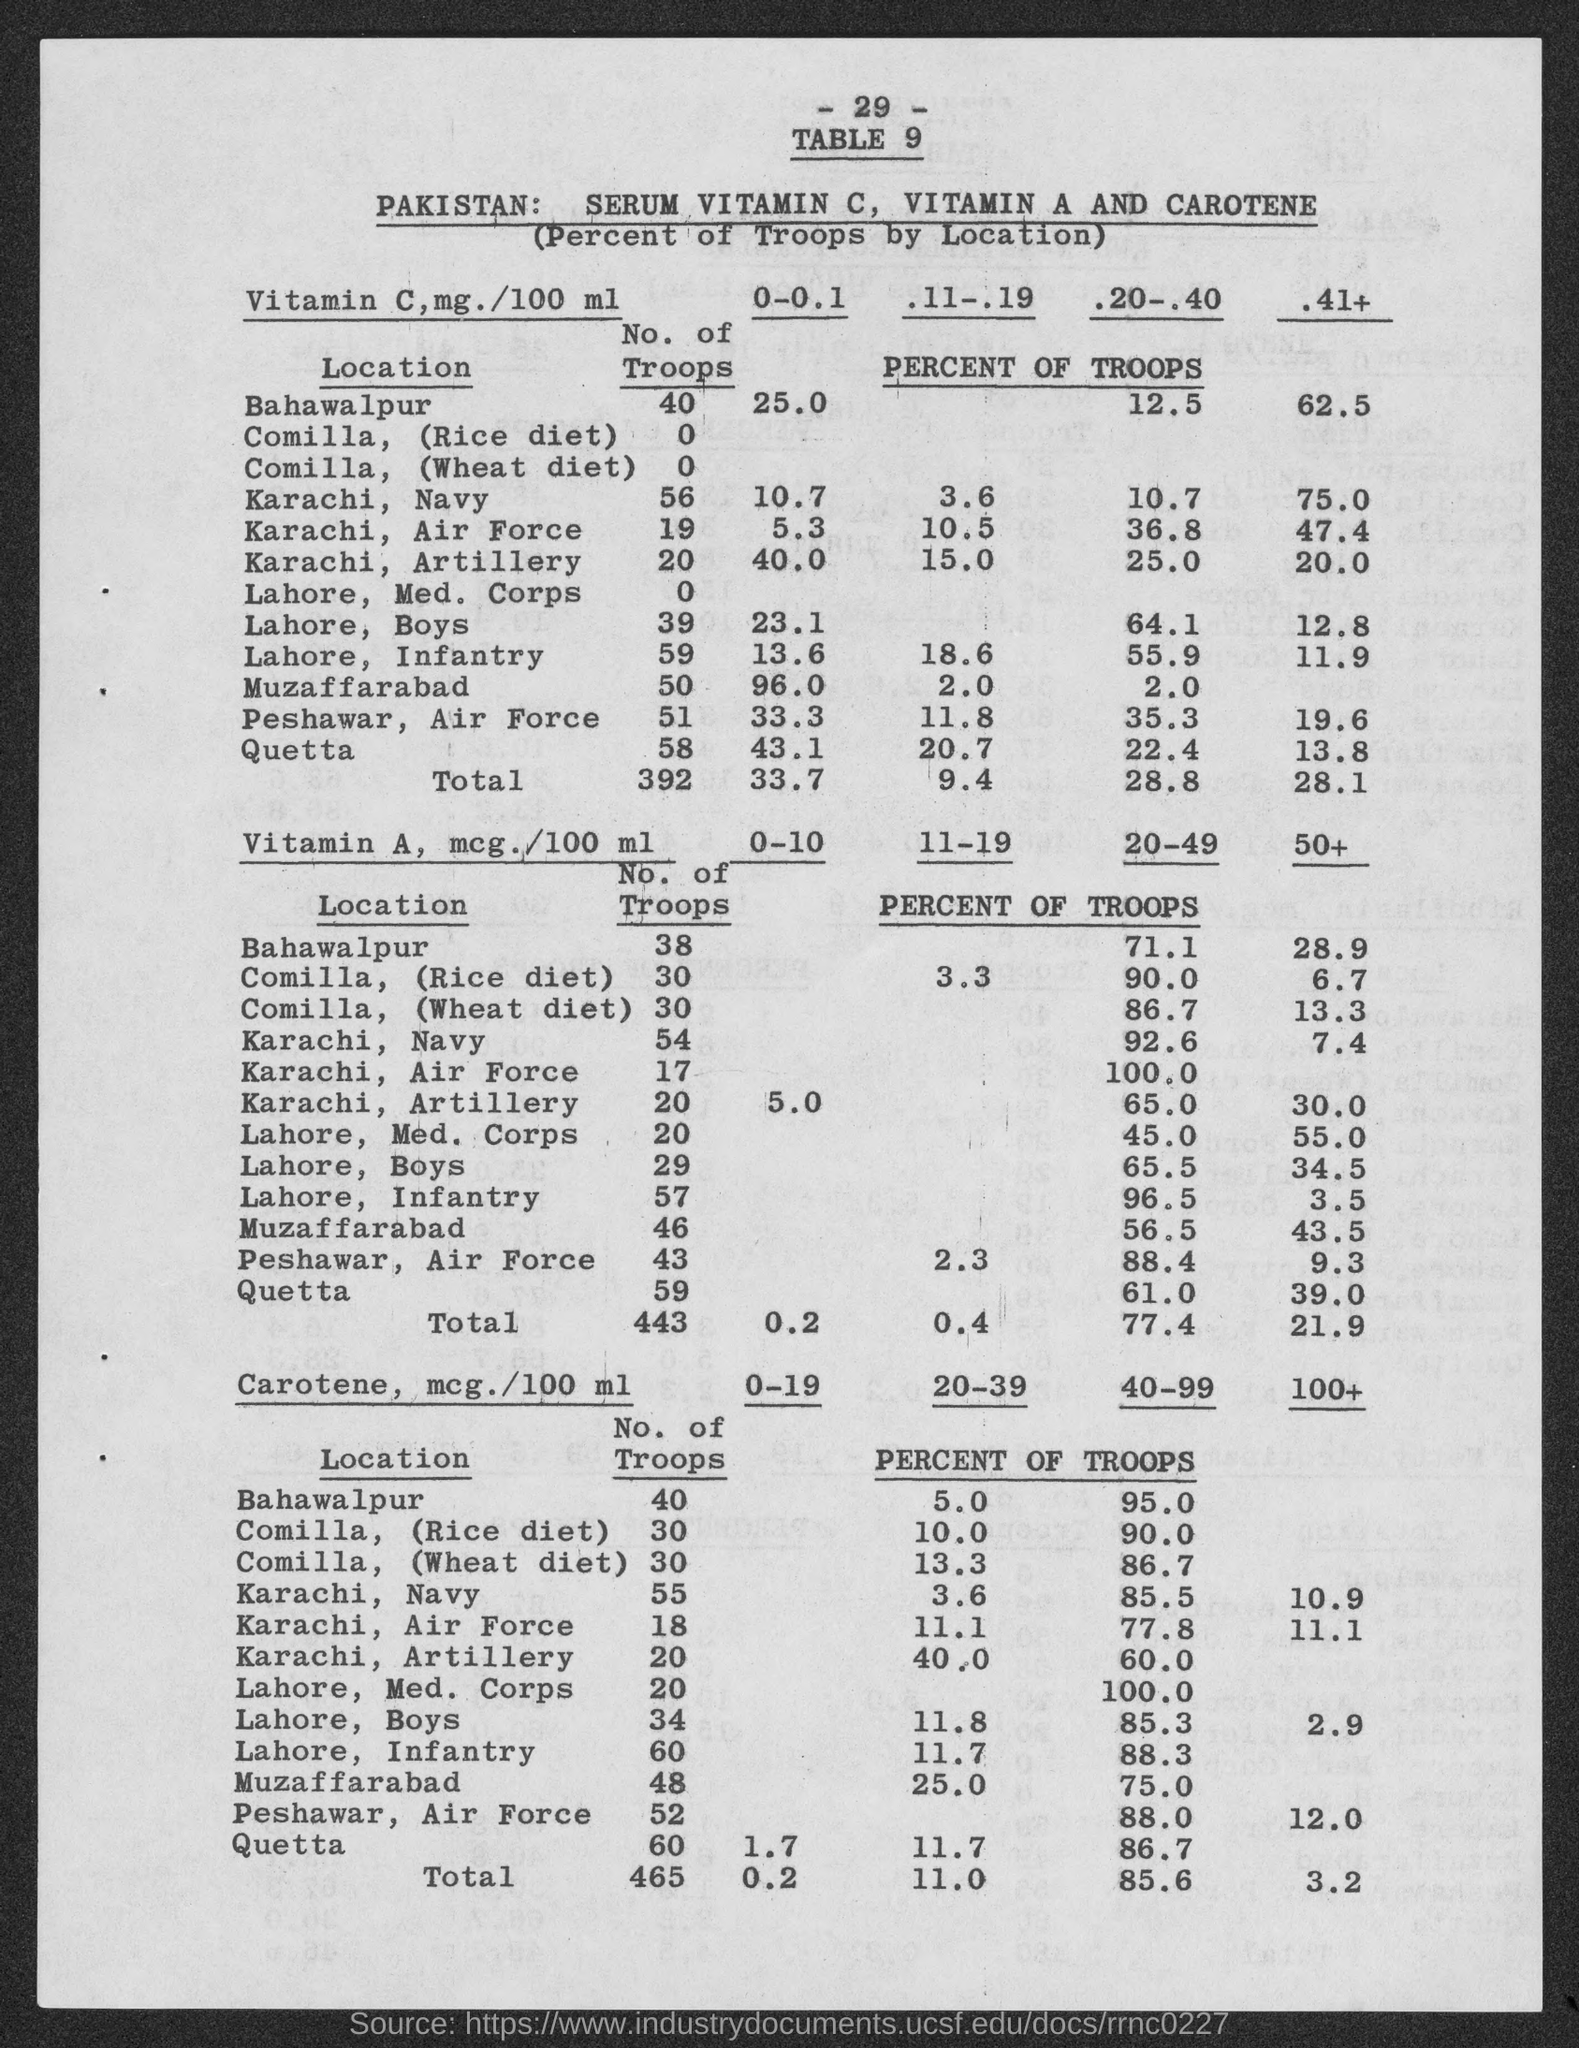What is the number at top of the page?
Give a very brief answer. -29-. What is the table no.?
Give a very brief answer. 9. What is the no. of troops under vitamin c in bahawalpur ?
Offer a very short reply. 40. What is the no. of troops under vitamin c in karachi, navy?
Your answer should be compact. 56. What is the no. of troops under vitamin c in karachi,  air force?
Offer a terse response. 19. What is the no. of troops under vitamin c in karachi, artillery ?
Provide a short and direct response. 20. What is the no. of troops under vitamin c in lahore, med. corps ?
Provide a succinct answer. 0. What is the no. of troops under vitamin c in lahore, boys ?
Offer a very short reply. 39. What is the no. of troops under vitamin c in lahore, infantry ?
Make the answer very short. 59. What is the no. of troops under vitamin c in muzaffarabad ?
Make the answer very short. 50. 